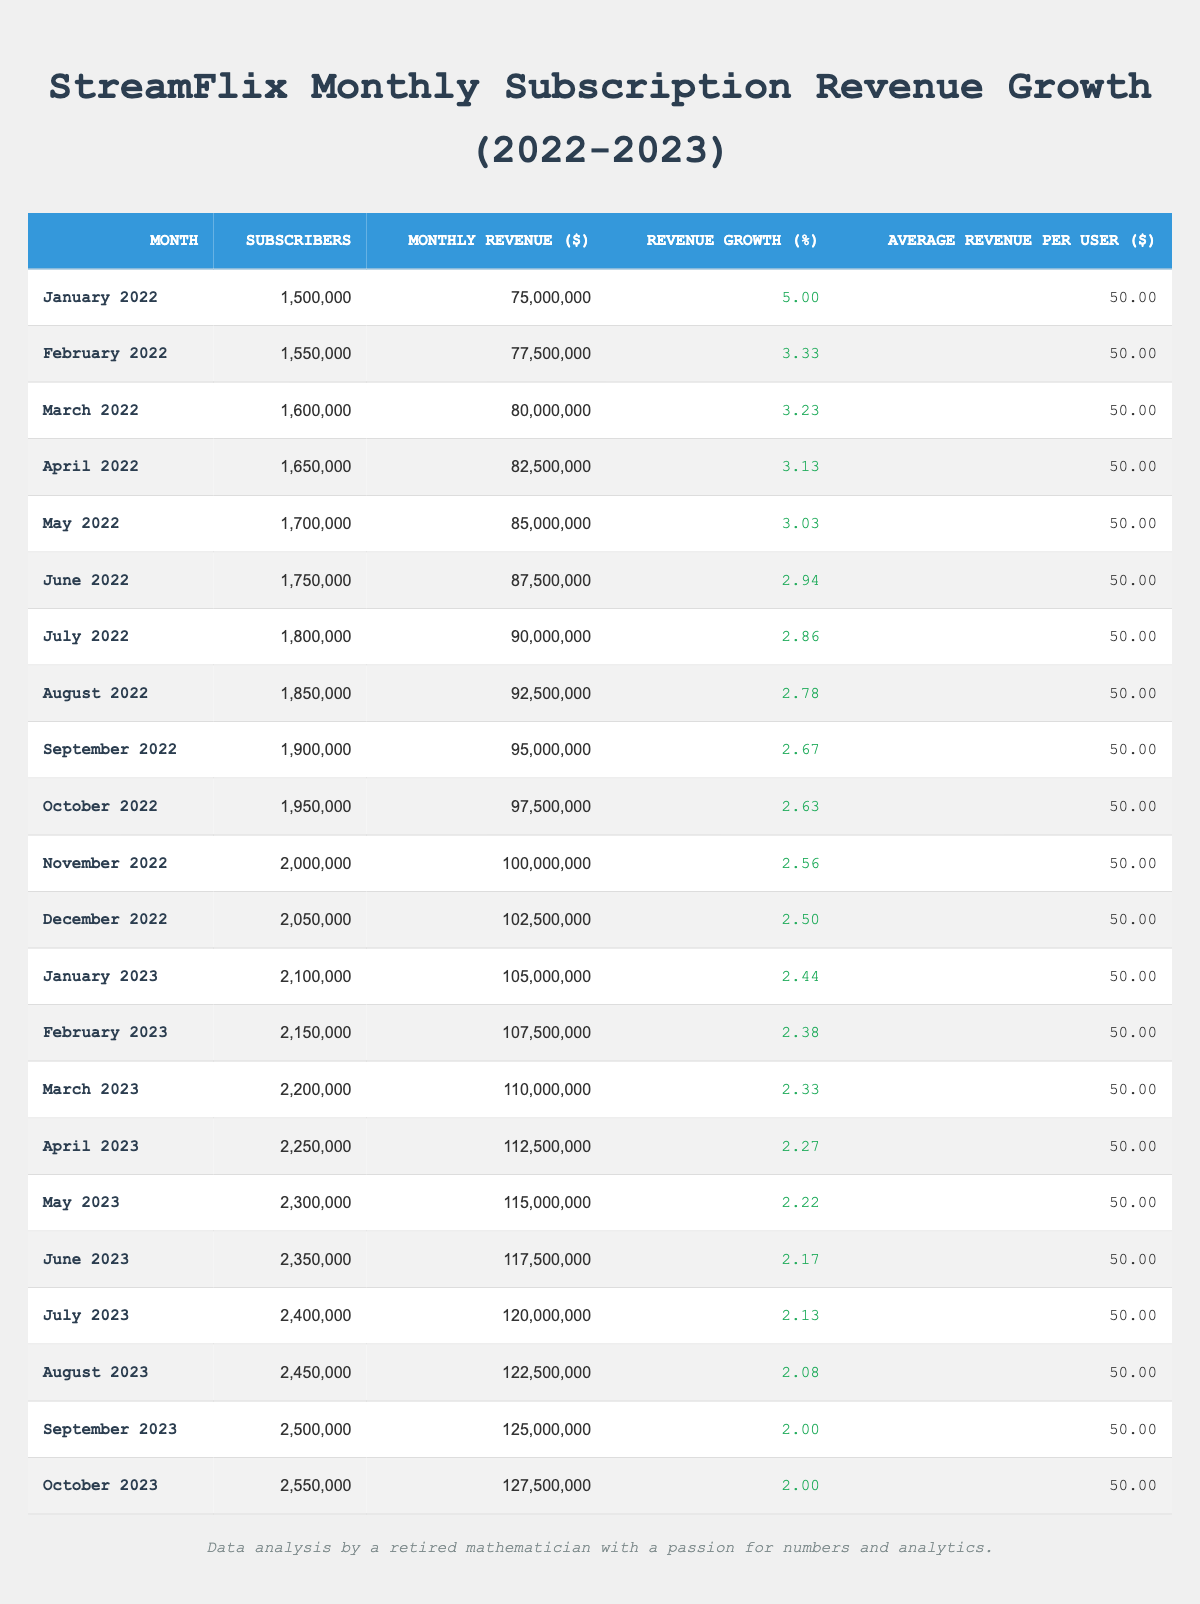What was the Monthly Revenue in December 2022? According to the table, the Monthly Revenue for December 2022 is listed as 102,500,000.
Answer: 102,500,000 What is the number of Subscribers in July 2022? The table shows that the number of Subscribers in July 2022 is 1,800,000.
Answer: 1,800,000 What is the Revenue Growth Percentage for August 2023? The table indicates that the Revenue Growth Percentage for August 2023 is 2.08%.
Answer: 2.08% What was the highest Monthly Revenue recorded in this data set? By reviewing the Monthly Revenue figures, the highest value is 127,500,000 in October 2023.
Answer: 127,500,000 How many Subscribers did StreamFlix gain from January 2022 to December 2023? In January 2022, there were 1,500,000 Subscribers and in October 2023, there were 2,550,000. The gain is 2,550,000 - 1,500,000 = 1,050,000.
Answer: 1,050,000 What was the average Monthly Revenue over the two years? The total Monthly Revenue from January 2022 to October 2023 is the sum of each month's value, which is 2,556,500,000, and there are 22 months. Therefore, the average is 2,556,500,000 / 22 = 116,250,000.
Answer: 116,250,000 Is the Average Revenue Per User consistent throughout the data set? Yes, the Average Revenue Per User is consistently recorded as 50.0 for every month in the data set.
Answer: Yes What is the difference in Monthly Revenue between March 2022 and March 2023? The Monthly Revenue for March 2022 is 80,000,000 and for March 2023 is 110,000,000. The difference is 110,000,000 - 80,000,000 = 30,000,000.
Answer: 30,000,000 How did the Monthly Revenue growth trend change from the beginning to the end of the data set? In January 2022, the Revenue Growth Percentage was 5.0%, but by October 2023, it dropped to 2.0%. This indicates a declining trend in growth over the period.
Answer: Declined What was the total number of Subscribers in December 2022? The table highlights that the number of Subscribers in December 2022 was 2,050,000.
Answer: 2,050,000 